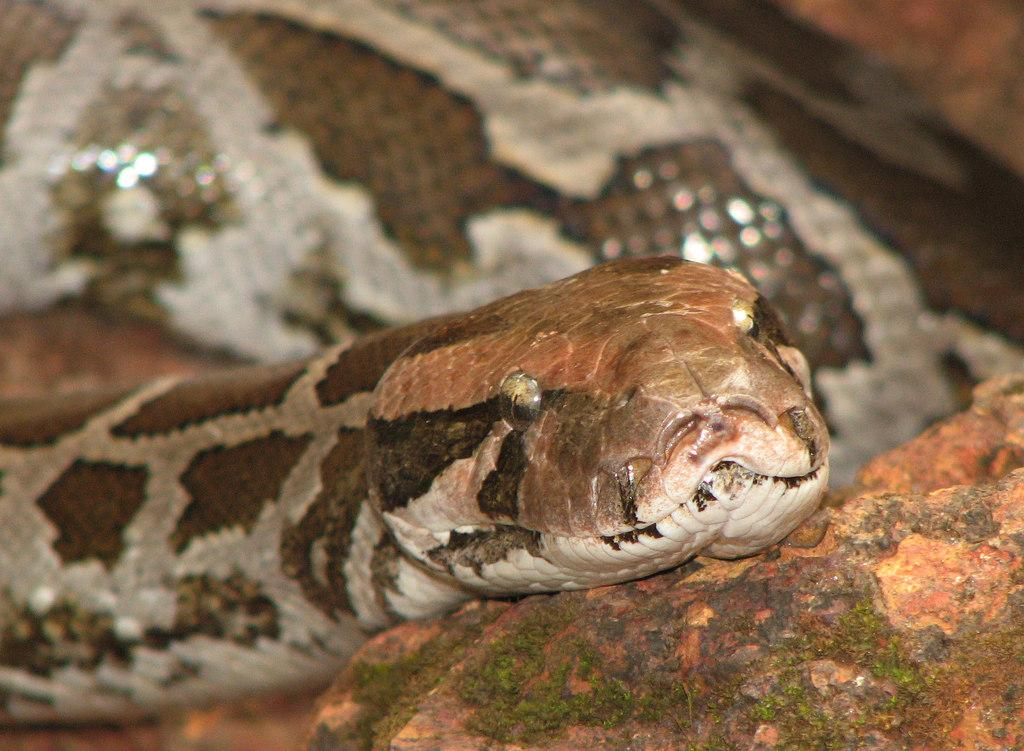What is the main subject in the center of the image? There is a snake in the center of the image. What other object can be seen in the image? There is a stone in the bottom right corner of the image. How much knowledge does the snake possess in the image? The image does not provide any information about the snake's knowledge, so it cannot be determined. 